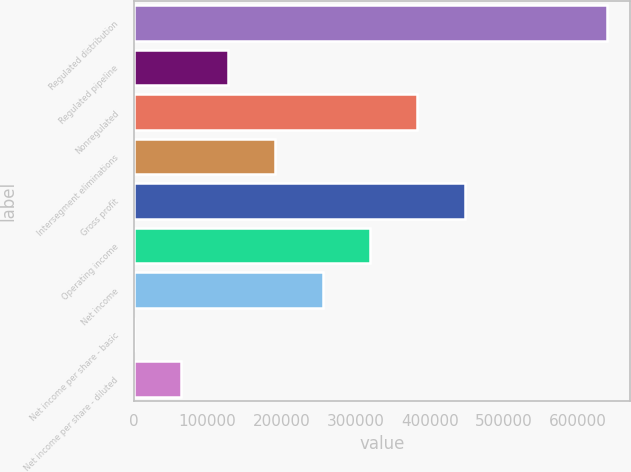Convert chart to OTSL. <chart><loc_0><loc_0><loc_500><loc_500><bar_chart><fcel>Regulated distribution<fcel>Regulated pipeline<fcel>Nonregulated<fcel>Intersegment eliminations<fcel>Gross profit<fcel>Operating income<fcel>Net income<fcel>Net income per share - basic<fcel>Net income per share - diluted<nl><fcel>638602<fcel>127721<fcel>383162<fcel>191581<fcel>447022<fcel>319302<fcel>255441<fcel>1<fcel>63861.1<nl></chart> 